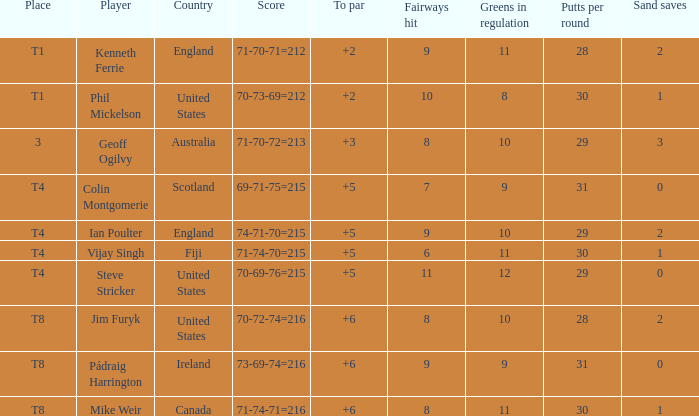What player was place of t1 in To Par and had a score of 70-73-69=212? 2.0. 